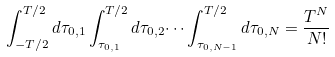Convert formula to latex. <formula><loc_0><loc_0><loc_500><loc_500>\int _ { - T / 2 } ^ { T / 2 } d \tau _ { 0 , 1 } \int _ { \tau _ { 0 , 1 } } ^ { T / 2 } d \tau _ { 0 , 2 } \dots \int _ { \tau _ { 0 , N - 1 } } ^ { T / 2 } d \tau _ { 0 , N } = \frac { T ^ { N } } { N ! }</formula> 